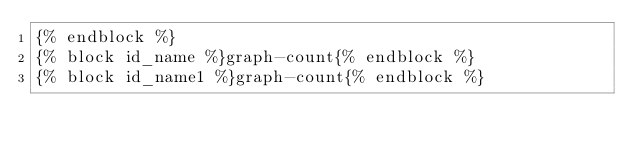Convert code to text. <code><loc_0><loc_0><loc_500><loc_500><_HTML_>{% endblock %}
{% block id_name %}graph-count{% endblock %}
{% block id_name1 %}graph-count{% endblock %}
</code> 